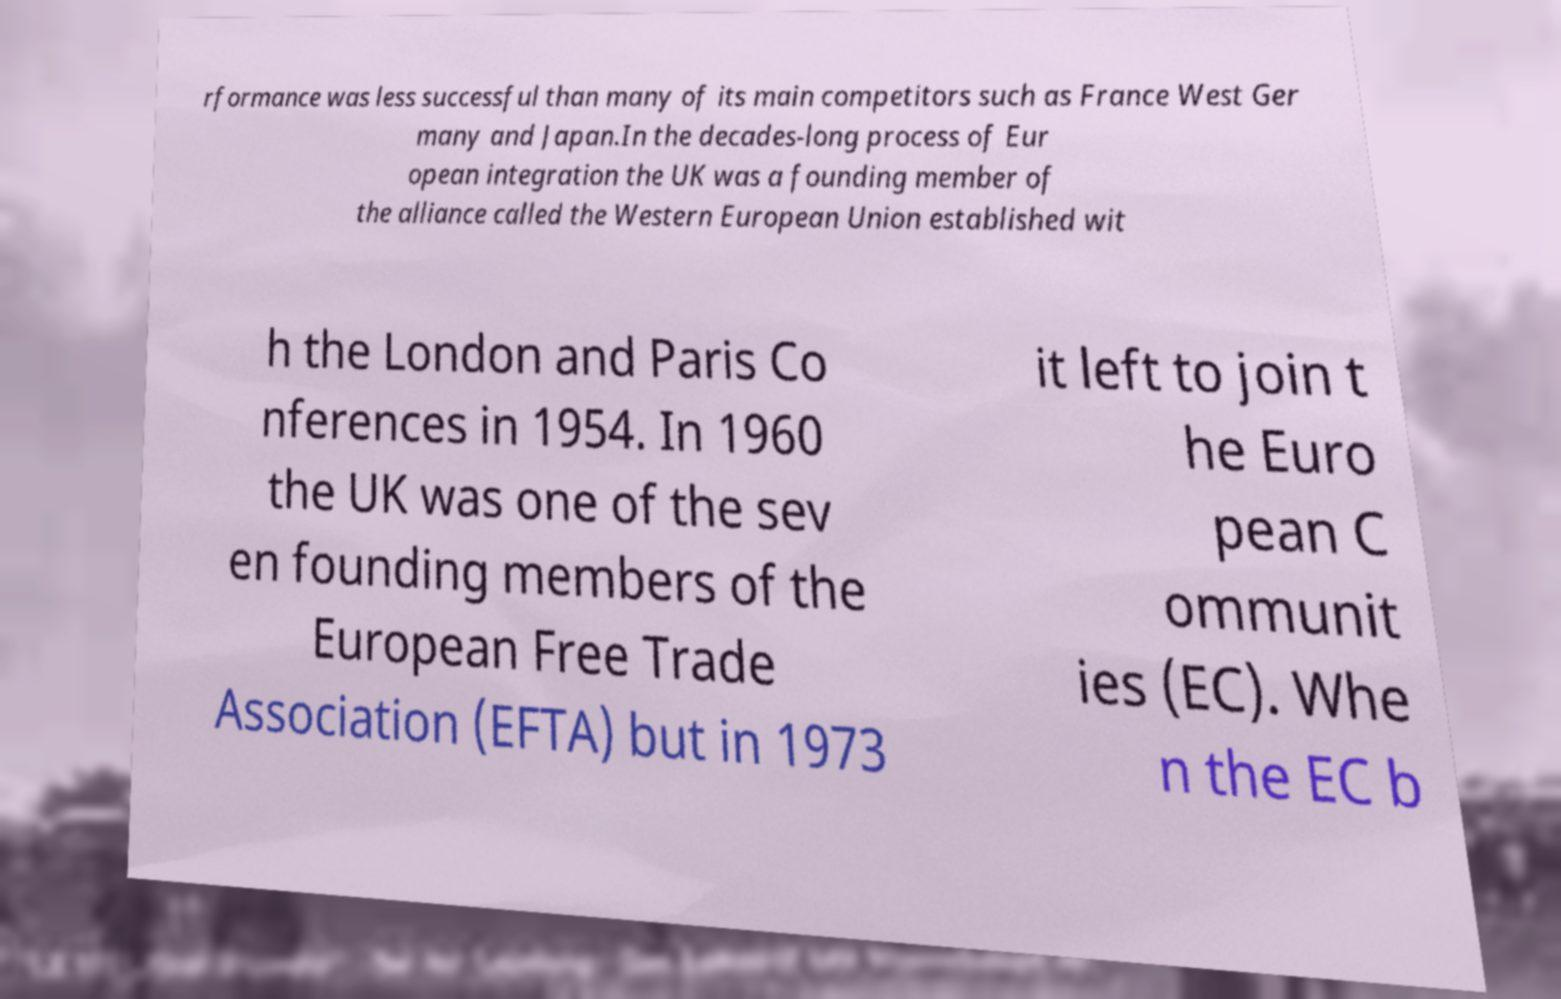Could you extract and type out the text from this image? rformance was less successful than many of its main competitors such as France West Ger many and Japan.In the decades-long process of Eur opean integration the UK was a founding member of the alliance called the Western European Union established wit h the London and Paris Co nferences in 1954. In 1960 the UK was one of the sev en founding members of the European Free Trade Association (EFTA) but in 1973 it left to join t he Euro pean C ommunit ies (EC). Whe n the EC b 